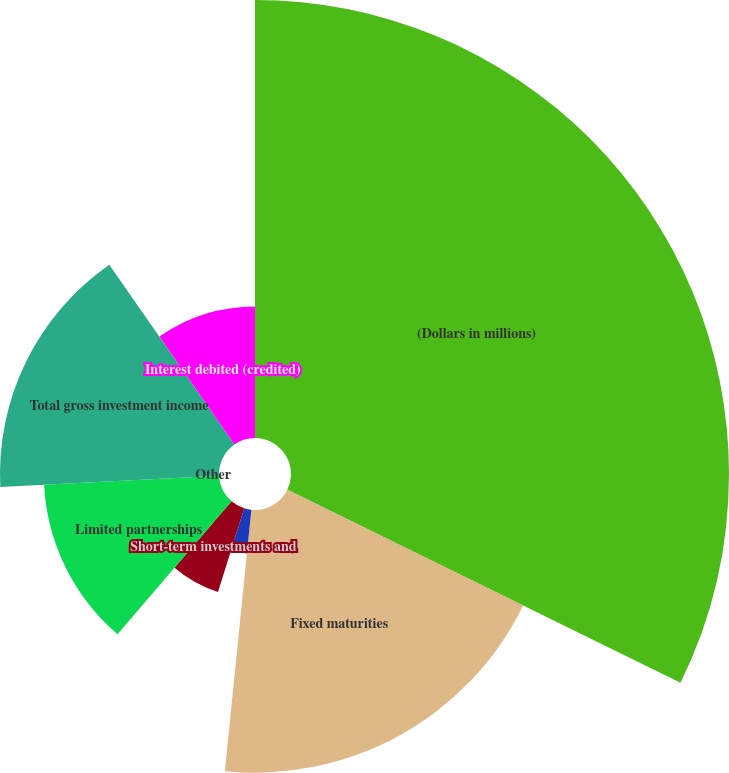<chart> <loc_0><loc_0><loc_500><loc_500><pie_chart><fcel>(Dollars in millions)<fcel>Fixed maturities<fcel>Equity securities<fcel>Short-term investments and<fcel>Limited partnerships<fcel>Other<fcel>Total gross investment income<fcel>Interest debited (credited)<nl><fcel>32.26%<fcel>19.35%<fcel>3.23%<fcel>6.45%<fcel>12.9%<fcel>0.0%<fcel>16.13%<fcel>9.68%<nl></chart> 